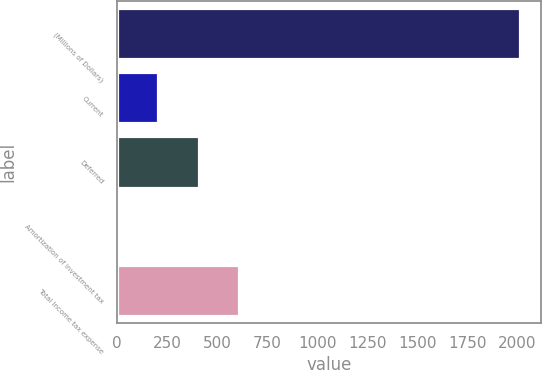Convert chart. <chart><loc_0><loc_0><loc_500><loc_500><bar_chart><fcel>(Millions of Dollars)<fcel>Current<fcel>Deferred<fcel>Amortization of investment tax<fcel>Total income tax expense<nl><fcel>2015<fcel>206<fcel>407<fcel>5<fcel>608<nl></chart> 